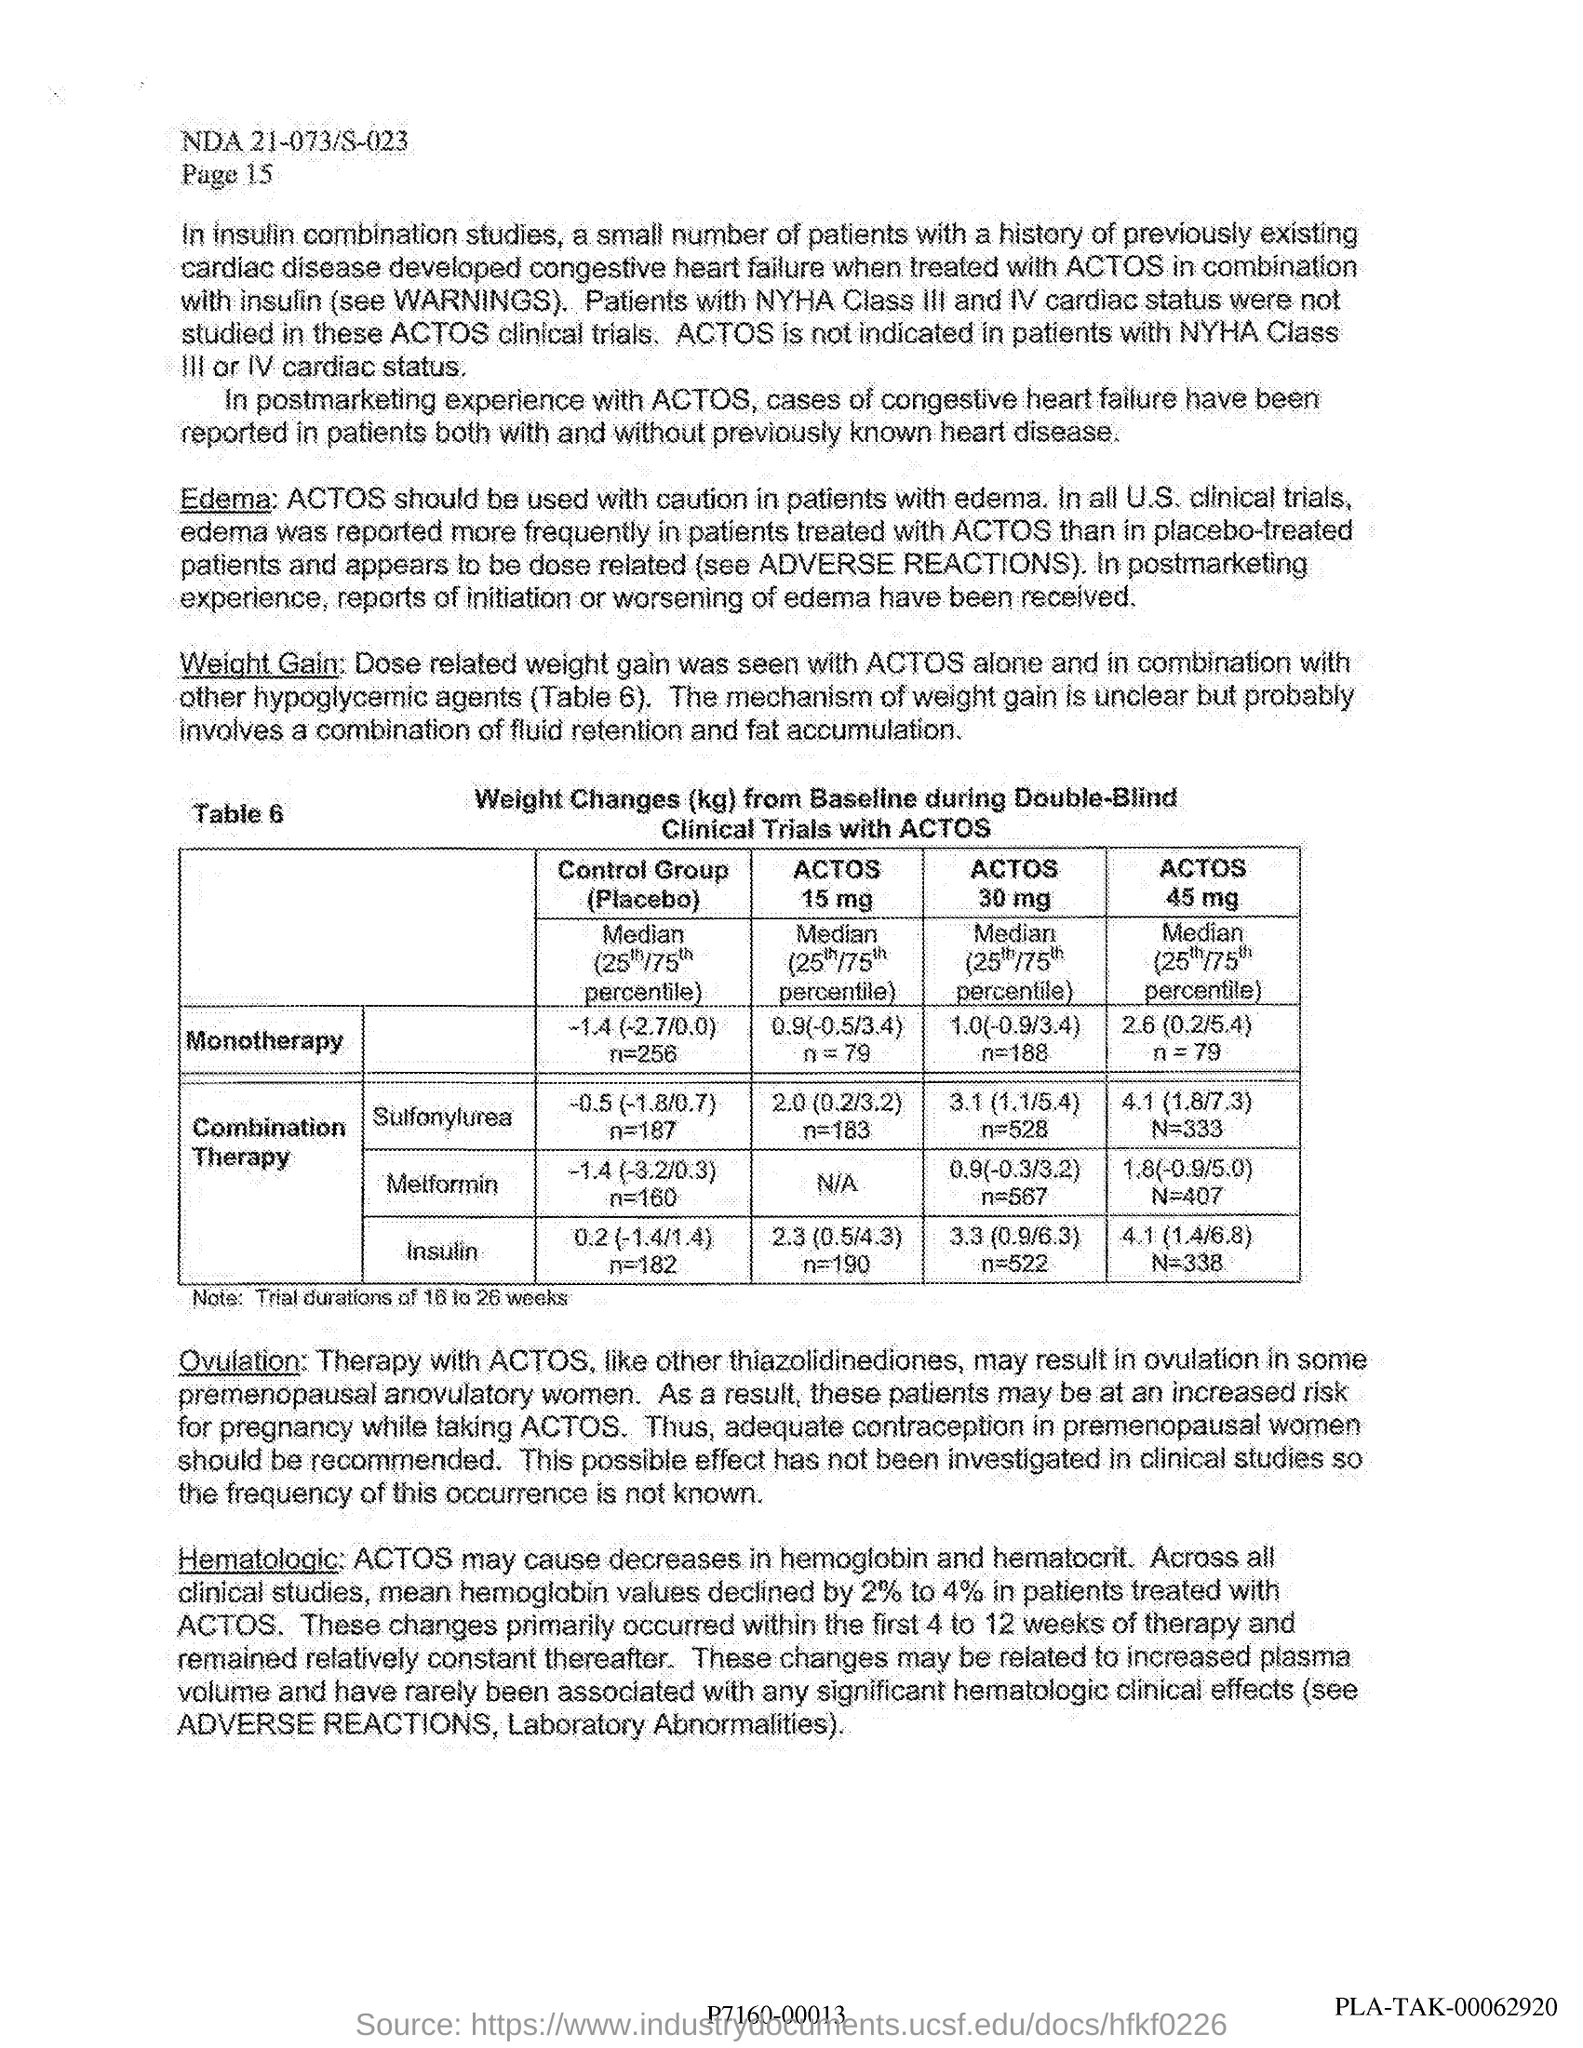What is the heading of the table?
Your response must be concise. Weight Changes (kg) from Baseline during Double-Blind Clinical Trials with ACTOS. What is the ACTOS 15 mg of Monotherapy?
Provide a succinct answer. 0.9(-0.5/3.4) n=79. What is the trial duration mentioned?
Ensure brevity in your answer.  16 to 26 weeks. What is the ACTOS 45 mg of Combination Therapy of Insulin?
Your response must be concise. 4.1 (1.4/6.8) N=338. 